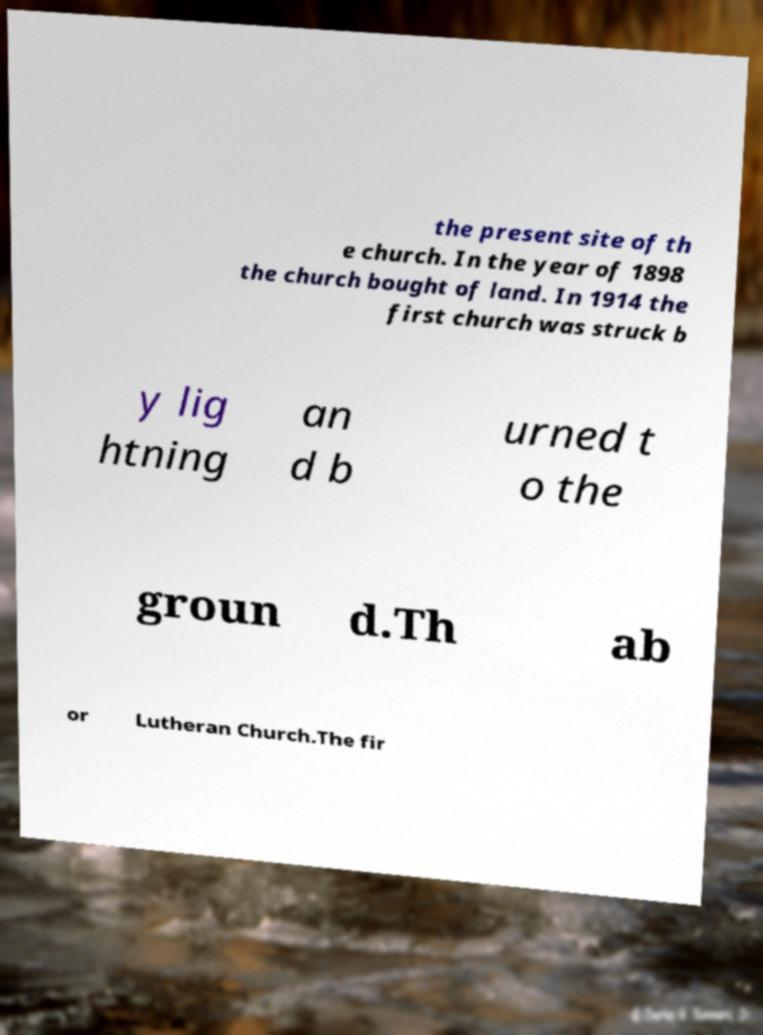Please identify and transcribe the text found in this image. the present site of th e church. In the year of 1898 the church bought of land. In 1914 the first church was struck b y lig htning an d b urned t o the groun d.Th ab or Lutheran Church.The fir 